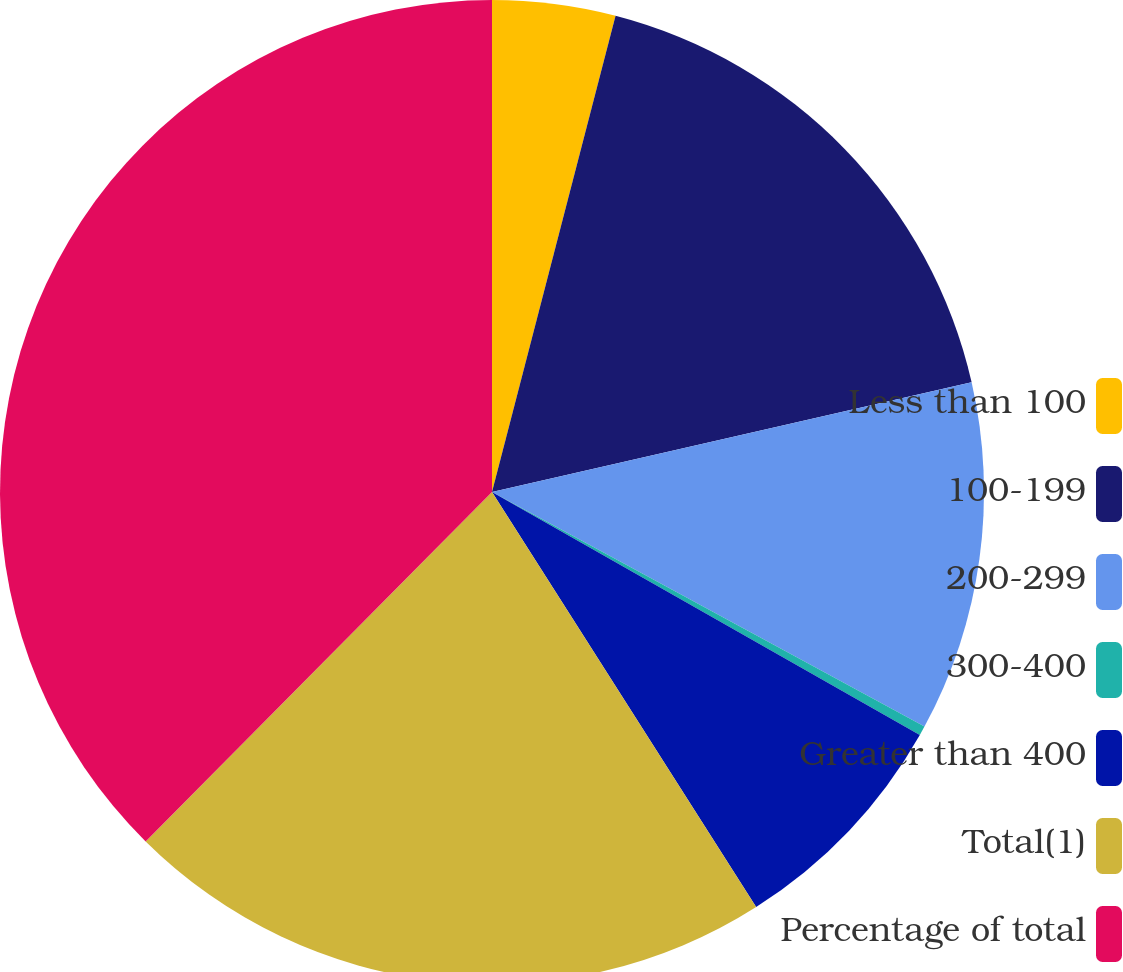Convert chart to OTSL. <chart><loc_0><loc_0><loc_500><loc_500><pie_chart><fcel>Less than 100<fcel>100-199<fcel>200-299<fcel>300-400<fcel>Greater than 400<fcel>Total(1)<fcel>Percentage of total<nl><fcel>4.04%<fcel>17.38%<fcel>11.49%<fcel>0.31%<fcel>7.76%<fcel>21.45%<fcel>37.57%<nl></chart> 